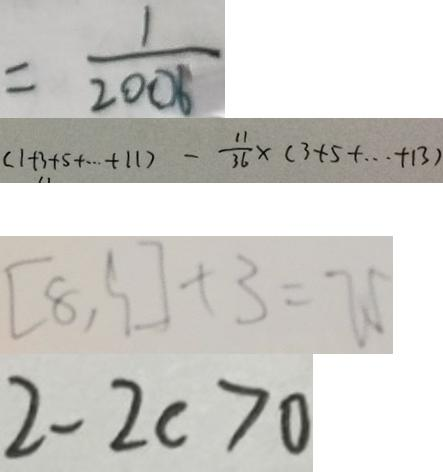<formula> <loc_0><loc_0><loc_500><loc_500>= \frac { 1 } { 2 0 0 6 } 
 ( 1 + 3 + 5 + \cdots + 1 1 ) - \frac { 1 1 } { 3 6 } \times ( 3 + 5 + \cdots + 1 3 ) 
 ( 8 , 9 ) + 3 = 7 5 
 2 - 2 c > 0</formula> 